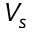Convert formula to latex. <formula><loc_0><loc_0><loc_500><loc_500>V _ { s }</formula> 